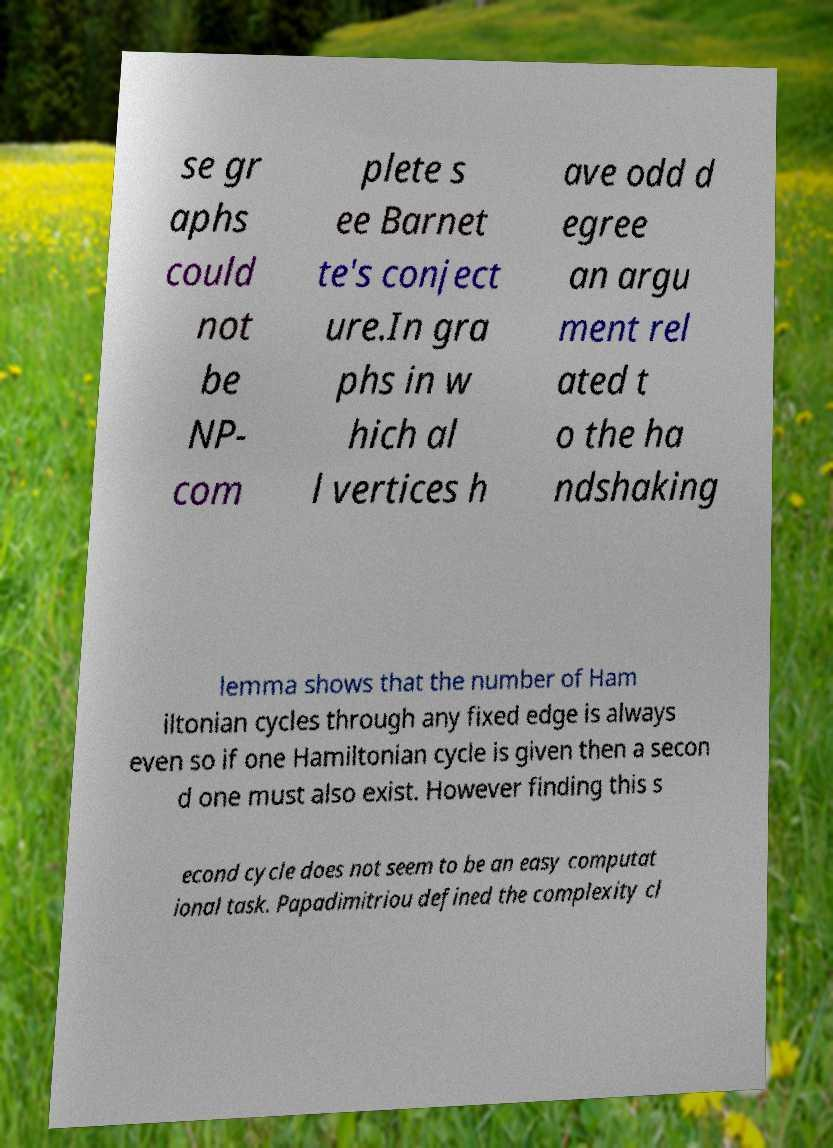Please read and relay the text visible in this image. What does it say? se gr aphs could not be NP- com plete s ee Barnet te's conject ure.In gra phs in w hich al l vertices h ave odd d egree an argu ment rel ated t o the ha ndshaking lemma shows that the number of Ham iltonian cycles through any fixed edge is always even so if one Hamiltonian cycle is given then a secon d one must also exist. However finding this s econd cycle does not seem to be an easy computat ional task. Papadimitriou defined the complexity cl 